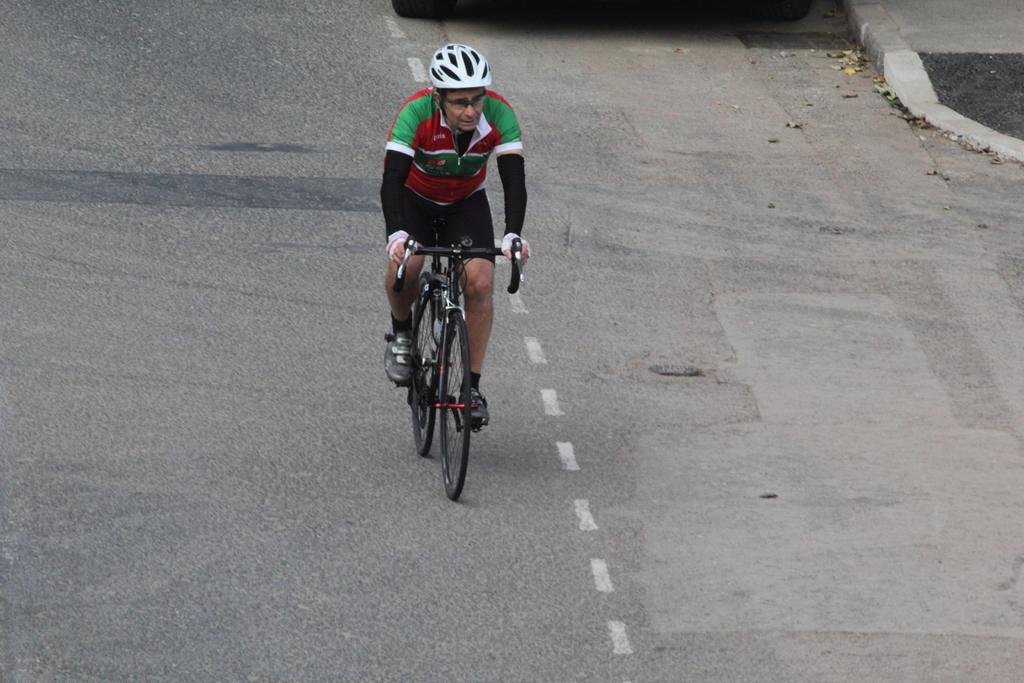Who is the main subject in the image? There is a man in the image. What is the man doing in the image? The man is riding a bicycle. Where is the bicycle located in the image? The bicycle is on a road. What type of beef can be seen on the road in the image? There is no beef present in the image; the man is riding a bicycle on a road. How many ladybugs are visible on the man's bicycle in the image? There are no ladybugs visible on the man's bicycle in the image. 